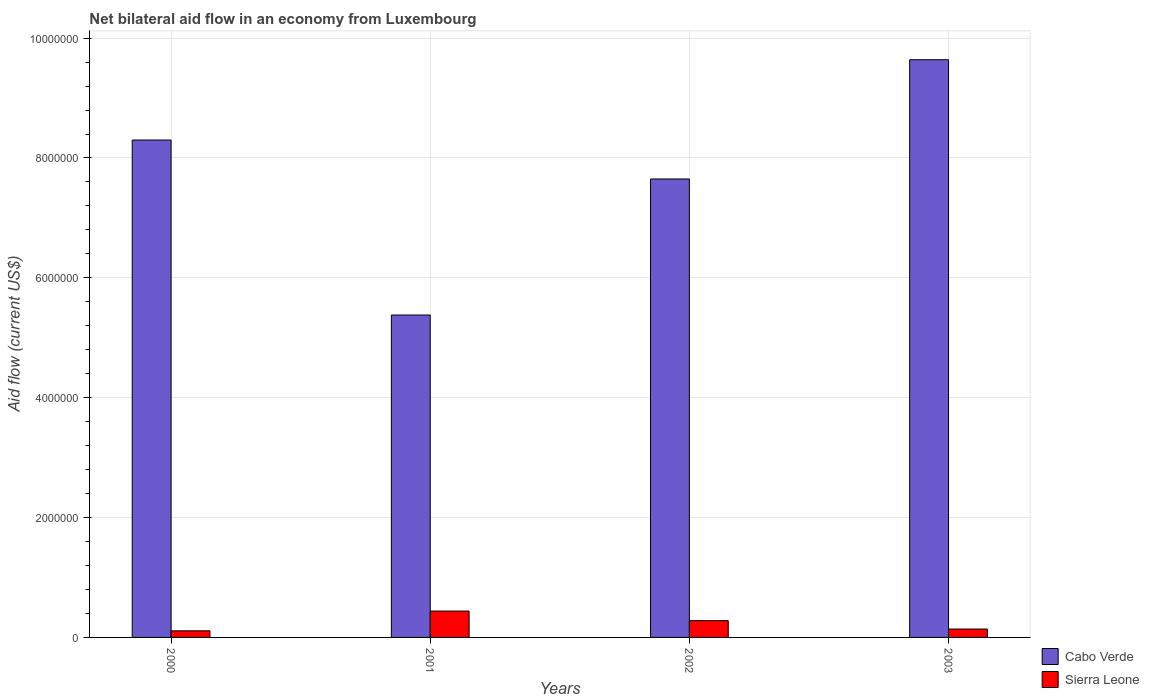How many different coloured bars are there?
Make the answer very short. 2. Are the number of bars per tick equal to the number of legend labels?
Your answer should be very brief. Yes. What is the label of the 4th group of bars from the left?
Make the answer very short. 2003. In how many cases, is the number of bars for a given year not equal to the number of legend labels?
Provide a succinct answer. 0. Across all years, what is the minimum net bilateral aid flow in Sierra Leone?
Your answer should be compact. 1.10e+05. What is the total net bilateral aid flow in Cabo Verde in the graph?
Keep it short and to the point. 3.10e+07. What is the difference between the net bilateral aid flow in Cabo Verde in 2000 and the net bilateral aid flow in Sierra Leone in 2001?
Offer a terse response. 7.86e+06. What is the average net bilateral aid flow in Sierra Leone per year?
Make the answer very short. 2.42e+05. In the year 2002, what is the difference between the net bilateral aid flow in Cabo Verde and net bilateral aid flow in Sierra Leone?
Provide a succinct answer. 7.37e+06. What is the ratio of the net bilateral aid flow in Sierra Leone in 2000 to that in 2002?
Provide a short and direct response. 0.39. Is the difference between the net bilateral aid flow in Cabo Verde in 2000 and 2003 greater than the difference between the net bilateral aid flow in Sierra Leone in 2000 and 2003?
Offer a very short reply. No. What is the difference between the highest and the second highest net bilateral aid flow in Sierra Leone?
Your response must be concise. 1.60e+05. What is the difference between the highest and the lowest net bilateral aid flow in Sierra Leone?
Provide a succinct answer. 3.30e+05. What does the 2nd bar from the left in 2000 represents?
Your answer should be compact. Sierra Leone. What does the 2nd bar from the right in 2002 represents?
Make the answer very short. Cabo Verde. How many bars are there?
Your answer should be compact. 8. Are all the bars in the graph horizontal?
Your answer should be compact. No. What is the difference between two consecutive major ticks on the Y-axis?
Ensure brevity in your answer.  2.00e+06. Does the graph contain any zero values?
Provide a short and direct response. No. Does the graph contain grids?
Provide a short and direct response. Yes. Where does the legend appear in the graph?
Make the answer very short. Bottom right. How many legend labels are there?
Offer a terse response. 2. How are the legend labels stacked?
Your answer should be compact. Vertical. What is the title of the graph?
Keep it short and to the point. Net bilateral aid flow in an economy from Luxembourg. Does "Saudi Arabia" appear as one of the legend labels in the graph?
Your answer should be very brief. No. What is the Aid flow (current US$) of Cabo Verde in 2000?
Your response must be concise. 8.30e+06. What is the Aid flow (current US$) of Cabo Verde in 2001?
Make the answer very short. 5.38e+06. What is the Aid flow (current US$) of Cabo Verde in 2002?
Give a very brief answer. 7.65e+06. What is the Aid flow (current US$) in Cabo Verde in 2003?
Keep it short and to the point. 9.64e+06. Across all years, what is the maximum Aid flow (current US$) of Cabo Verde?
Offer a very short reply. 9.64e+06. Across all years, what is the minimum Aid flow (current US$) in Cabo Verde?
Offer a terse response. 5.38e+06. What is the total Aid flow (current US$) in Cabo Verde in the graph?
Keep it short and to the point. 3.10e+07. What is the total Aid flow (current US$) of Sierra Leone in the graph?
Provide a succinct answer. 9.70e+05. What is the difference between the Aid flow (current US$) in Cabo Verde in 2000 and that in 2001?
Offer a terse response. 2.92e+06. What is the difference between the Aid flow (current US$) in Sierra Leone in 2000 and that in 2001?
Your answer should be very brief. -3.30e+05. What is the difference between the Aid flow (current US$) of Cabo Verde in 2000 and that in 2002?
Provide a short and direct response. 6.50e+05. What is the difference between the Aid flow (current US$) in Sierra Leone in 2000 and that in 2002?
Make the answer very short. -1.70e+05. What is the difference between the Aid flow (current US$) of Cabo Verde in 2000 and that in 2003?
Your response must be concise. -1.34e+06. What is the difference between the Aid flow (current US$) in Sierra Leone in 2000 and that in 2003?
Your answer should be compact. -3.00e+04. What is the difference between the Aid flow (current US$) of Cabo Verde in 2001 and that in 2002?
Give a very brief answer. -2.27e+06. What is the difference between the Aid flow (current US$) of Cabo Verde in 2001 and that in 2003?
Provide a short and direct response. -4.26e+06. What is the difference between the Aid flow (current US$) of Cabo Verde in 2002 and that in 2003?
Provide a succinct answer. -1.99e+06. What is the difference between the Aid flow (current US$) of Cabo Verde in 2000 and the Aid flow (current US$) of Sierra Leone in 2001?
Make the answer very short. 7.86e+06. What is the difference between the Aid flow (current US$) in Cabo Verde in 2000 and the Aid flow (current US$) in Sierra Leone in 2002?
Offer a very short reply. 8.02e+06. What is the difference between the Aid flow (current US$) in Cabo Verde in 2000 and the Aid flow (current US$) in Sierra Leone in 2003?
Offer a very short reply. 8.16e+06. What is the difference between the Aid flow (current US$) of Cabo Verde in 2001 and the Aid flow (current US$) of Sierra Leone in 2002?
Provide a succinct answer. 5.10e+06. What is the difference between the Aid flow (current US$) of Cabo Verde in 2001 and the Aid flow (current US$) of Sierra Leone in 2003?
Make the answer very short. 5.24e+06. What is the difference between the Aid flow (current US$) in Cabo Verde in 2002 and the Aid flow (current US$) in Sierra Leone in 2003?
Your answer should be compact. 7.51e+06. What is the average Aid flow (current US$) of Cabo Verde per year?
Provide a succinct answer. 7.74e+06. What is the average Aid flow (current US$) in Sierra Leone per year?
Ensure brevity in your answer.  2.42e+05. In the year 2000, what is the difference between the Aid flow (current US$) of Cabo Verde and Aid flow (current US$) of Sierra Leone?
Offer a very short reply. 8.19e+06. In the year 2001, what is the difference between the Aid flow (current US$) in Cabo Verde and Aid flow (current US$) in Sierra Leone?
Keep it short and to the point. 4.94e+06. In the year 2002, what is the difference between the Aid flow (current US$) in Cabo Verde and Aid flow (current US$) in Sierra Leone?
Your answer should be very brief. 7.37e+06. In the year 2003, what is the difference between the Aid flow (current US$) in Cabo Verde and Aid flow (current US$) in Sierra Leone?
Offer a very short reply. 9.50e+06. What is the ratio of the Aid flow (current US$) of Cabo Verde in 2000 to that in 2001?
Ensure brevity in your answer.  1.54. What is the ratio of the Aid flow (current US$) in Cabo Verde in 2000 to that in 2002?
Your response must be concise. 1.08. What is the ratio of the Aid flow (current US$) of Sierra Leone in 2000 to that in 2002?
Offer a very short reply. 0.39. What is the ratio of the Aid flow (current US$) in Cabo Verde in 2000 to that in 2003?
Make the answer very short. 0.86. What is the ratio of the Aid flow (current US$) of Sierra Leone in 2000 to that in 2003?
Your answer should be compact. 0.79. What is the ratio of the Aid flow (current US$) of Cabo Verde in 2001 to that in 2002?
Your answer should be compact. 0.7. What is the ratio of the Aid flow (current US$) of Sierra Leone in 2001 to that in 2002?
Offer a terse response. 1.57. What is the ratio of the Aid flow (current US$) of Cabo Verde in 2001 to that in 2003?
Provide a short and direct response. 0.56. What is the ratio of the Aid flow (current US$) in Sierra Leone in 2001 to that in 2003?
Offer a terse response. 3.14. What is the ratio of the Aid flow (current US$) of Cabo Verde in 2002 to that in 2003?
Ensure brevity in your answer.  0.79. What is the ratio of the Aid flow (current US$) in Sierra Leone in 2002 to that in 2003?
Offer a very short reply. 2. What is the difference between the highest and the second highest Aid flow (current US$) in Cabo Verde?
Provide a succinct answer. 1.34e+06. What is the difference between the highest and the lowest Aid flow (current US$) in Cabo Verde?
Offer a very short reply. 4.26e+06. 